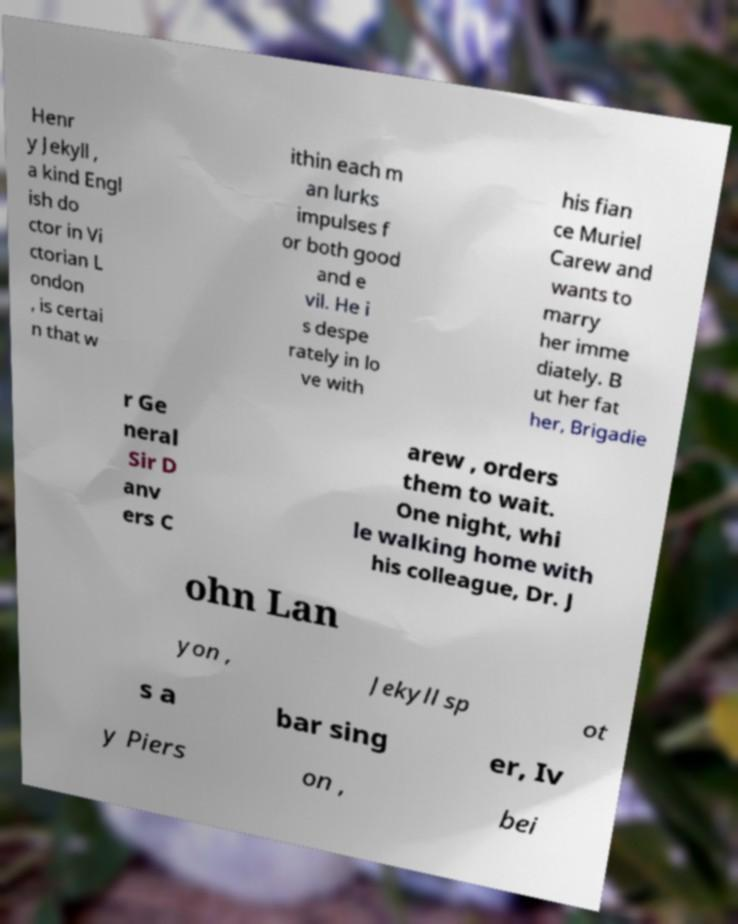For documentation purposes, I need the text within this image transcribed. Could you provide that? Henr y Jekyll , a kind Engl ish do ctor in Vi ctorian L ondon , is certai n that w ithin each m an lurks impulses f or both good and e vil. He i s despe rately in lo ve with his fian ce Muriel Carew and wants to marry her imme diately. B ut her fat her, Brigadie r Ge neral Sir D anv ers C arew , orders them to wait. One night, whi le walking home with his colleague, Dr. J ohn Lan yon , Jekyll sp ot s a bar sing er, Iv y Piers on , bei 